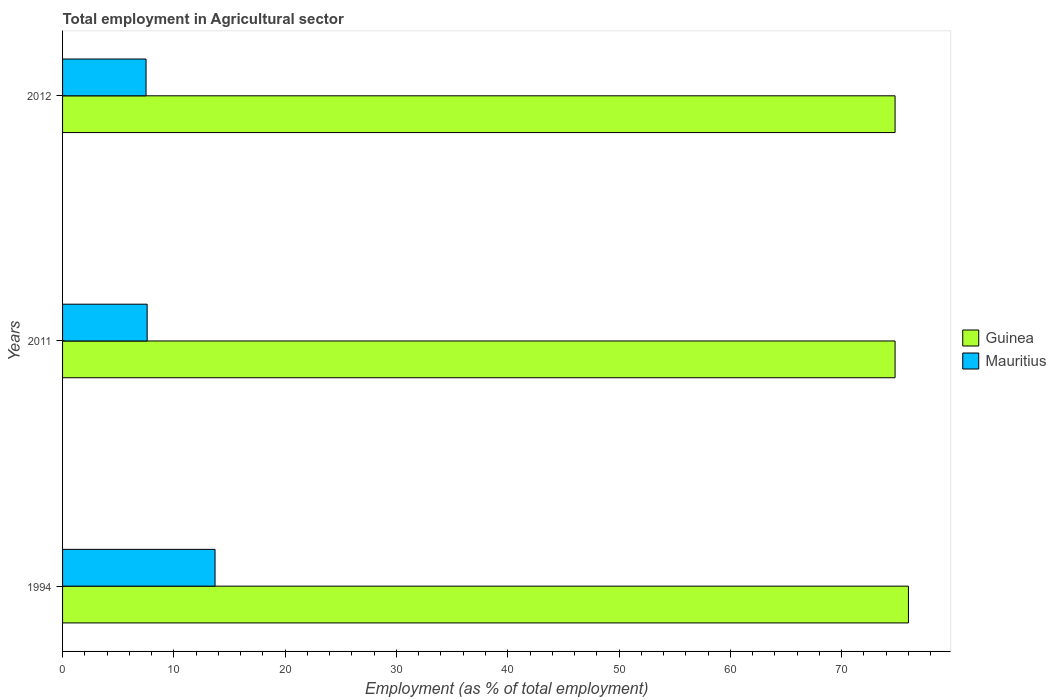How many groups of bars are there?
Keep it short and to the point. 3. How many bars are there on the 1st tick from the top?
Provide a short and direct response. 2. How many bars are there on the 1st tick from the bottom?
Make the answer very short. 2. What is the label of the 2nd group of bars from the top?
Your answer should be compact. 2011. What is the employment in agricultural sector in Guinea in 2012?
Give a very brief answer. 74.8. Across all years, what is the maximum employment in agricultural sector in Guinea?
Your response must be concise. 76. Across all years, what is the minimum employment in agricultural sector in Guinea?
Offer a terse response. 74.8. In which year was the employment in agricultural sector in Guinea maximum?
Make the answer very short. 1994. What is the total employment in agricultural sector in Guinea in the graph?
Ensure brevity in your answer.  225.6. What is the difference between the employment in agricultural sector in Mauritius in 1994 and the employment in agricultural sector in Guinea in 2012?
Ensure brevity in your answer.  -61.1. What is the average employment in agricultural sector in Mauritius per year?
Make the answer very short. 9.6. In the year 1994, what is the difference between the employment in agricultural sector in Guinea and employment in agricultural sector in Mauritius?
Offer a terse response. 62.3. In how many years, is the employment in agricultural sector in Guinea greater than 40 %?
Offer a terse response. 3. What is the ratio of the employment in agricultural sector in Guinea in 1994 to that in 2011?
Provide a short and direct response. 1.02. What is the difference between the highest and the second highest employment in agricultural sector in Mauritius?
Give a very brief answer. 6.1. What is the difference between the highest and the lowest employment in agricultural sector in Mauritius?
Provide a succinct answer. 6.2. In how many years, is the employment in agricultural sector in Mauritius greater than the average employment in agricultural sector in Mauritius taken over all years?
Your answer should be very brief. 1. What does the 2nd bar from the top in 1994 represents?
Offer a very short reply. Guinea. What does the 1st bar from the bottom in 1994 represents?
Make the answer very short. Guinea. How many bars are there?
Provide a succinct answer. 6. What is the difference between two consecutive major ticks on the X-axis?
Make the answer very short. 10. Are the values on the major ticks of X-axis written in scientific E-notation?
Provide a succinct answer. No. Does the graph contain grids?
Your response must be concise. No. How are the legend labels stacked?
Provide a short and direct response. Vertical. What is the title of the graph?
Your answer should be very brief. Total employment in Agricultural sector. What is the label or title of the X-axis?
Offer a terse response. Employment (as % of total employment). What is the Employment (as % of total employment) in Mauritius in 1994?
Offer a very short reply. 13.7. What is the Employment (as % of total employment) in Guinea in 2011?
Give a very brief answer. 74.8. What is the Employment (as % of total employment) of Mauritius in 2011?
Provide a succinct answer. 7.6. What is the Employment (as % of total employment) in Guinea in 2012?
Offer a very short reply. 74.8. What is the Employment (as % of total employment) in Mauritius in 2012?
Provide a short and direct response. 7.5. Across all years, what is the maximum Employment (as % of total employment) of Mauritius?
Give a very brief answer. 13.7. Across all years, what is the minimum Employment (as % of total employment) of Guinea?
Make the answer very short. 74.8. What is the total Employment (as % of total employment) of Guinea in the graph?
Offer a very short reply. 225.6. What is the total Employment (as % of total employment) in Mauritius in the graph?
Give a very brief answer. 28.8. What is the difference between the Employment (as % of total employment) of Guinea in 1994 and that in 2011?
Offer a terse response. 1.2. What is the difference between the Employment (as % of total employment) in Mauritius in 1994 and that in 2012?
Offer a terse response. 6.2. What is the difference between the Employment (as % of total employment) in Guinea in 1994 and the Employment (as % of total employment) in Mauritius in 2011?
Ensure brevity in your answer.  68.4. What is the difference between the Employment (as % of total employment) of Guinea in 1994 and the Employment (as % of total employment) of Mauritius in 2012?
Your answer should be very brief. 68.5. What is the difference between the Employment (as % of total employment) in Guinea in 2011 and the Employment (as % of total employment) in Mauritius in 2012?
Give a very brief answer. 67.3. What is the average Employment (as % of total employment) of Guinea per year?
Your answer should be compact. 75.2. What is the average Employment (as % of total employment) in Mauritius per year?
Provide a succinct answer. 9.6. In the year 1994, what is the difference between the Employment (as % of total employment) in Guinea and Employment (as % of total employment) in Mauritius?
Provide a succinct answer. 62.3. In the year 2011, what is the difference between the Employment (as % of total employment) in Guinea and Employment (as % of total employment) in Mauritius?
Your answer should be very brief. 67.2. In the year 2012, what is the difference between the Employment (as % of total employment) of Guinea and Employment (as % of total employment) of Mauritius?
Offer a very short reply. 67.3. What is the ratio of the Employment (as % of total employment) of Mauritius in 1994 to that in 2011?
Keep it short and to the point. 1.8. What is the ratio of the Employment (as % of total employment) in Guinea in 1994 to that in 2012?
Provide a short and direct response. 1.02. What is the ratio of the Employment (as % of total employment) in Mauritius in 1994 to that in 2012?
Your answer should be compact. 1.83. What is the ratio of the Employment (as % of total employment) of Guinea in 2011 to that in 2012?
Provide a succinct answer. 1. What is the ratio of the Employment (as % of total employment) of Mauritius in 2011 to that in 2012?
Provide a short and direct response. 1.01. What is the difference between the highest and the second highest Employment (as % of total employment) of Guinea?
Give a very brief answer. 1.2. What is the difference between the highest and the second highest Employment (as % of total employment) of Mauritius?
Your answer should be very brief. 6.1. What is the difference between the highest and the lowest Employment (as % of total employment) of Mauritius?
Your answer should be compact. 6.2. 